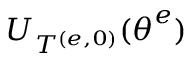<formula> <loc_0><loc_0><loc_500><loc_500>U _ { T ^ { ( e , 0 ) } } ( \theta ^ { e } )</formula> 